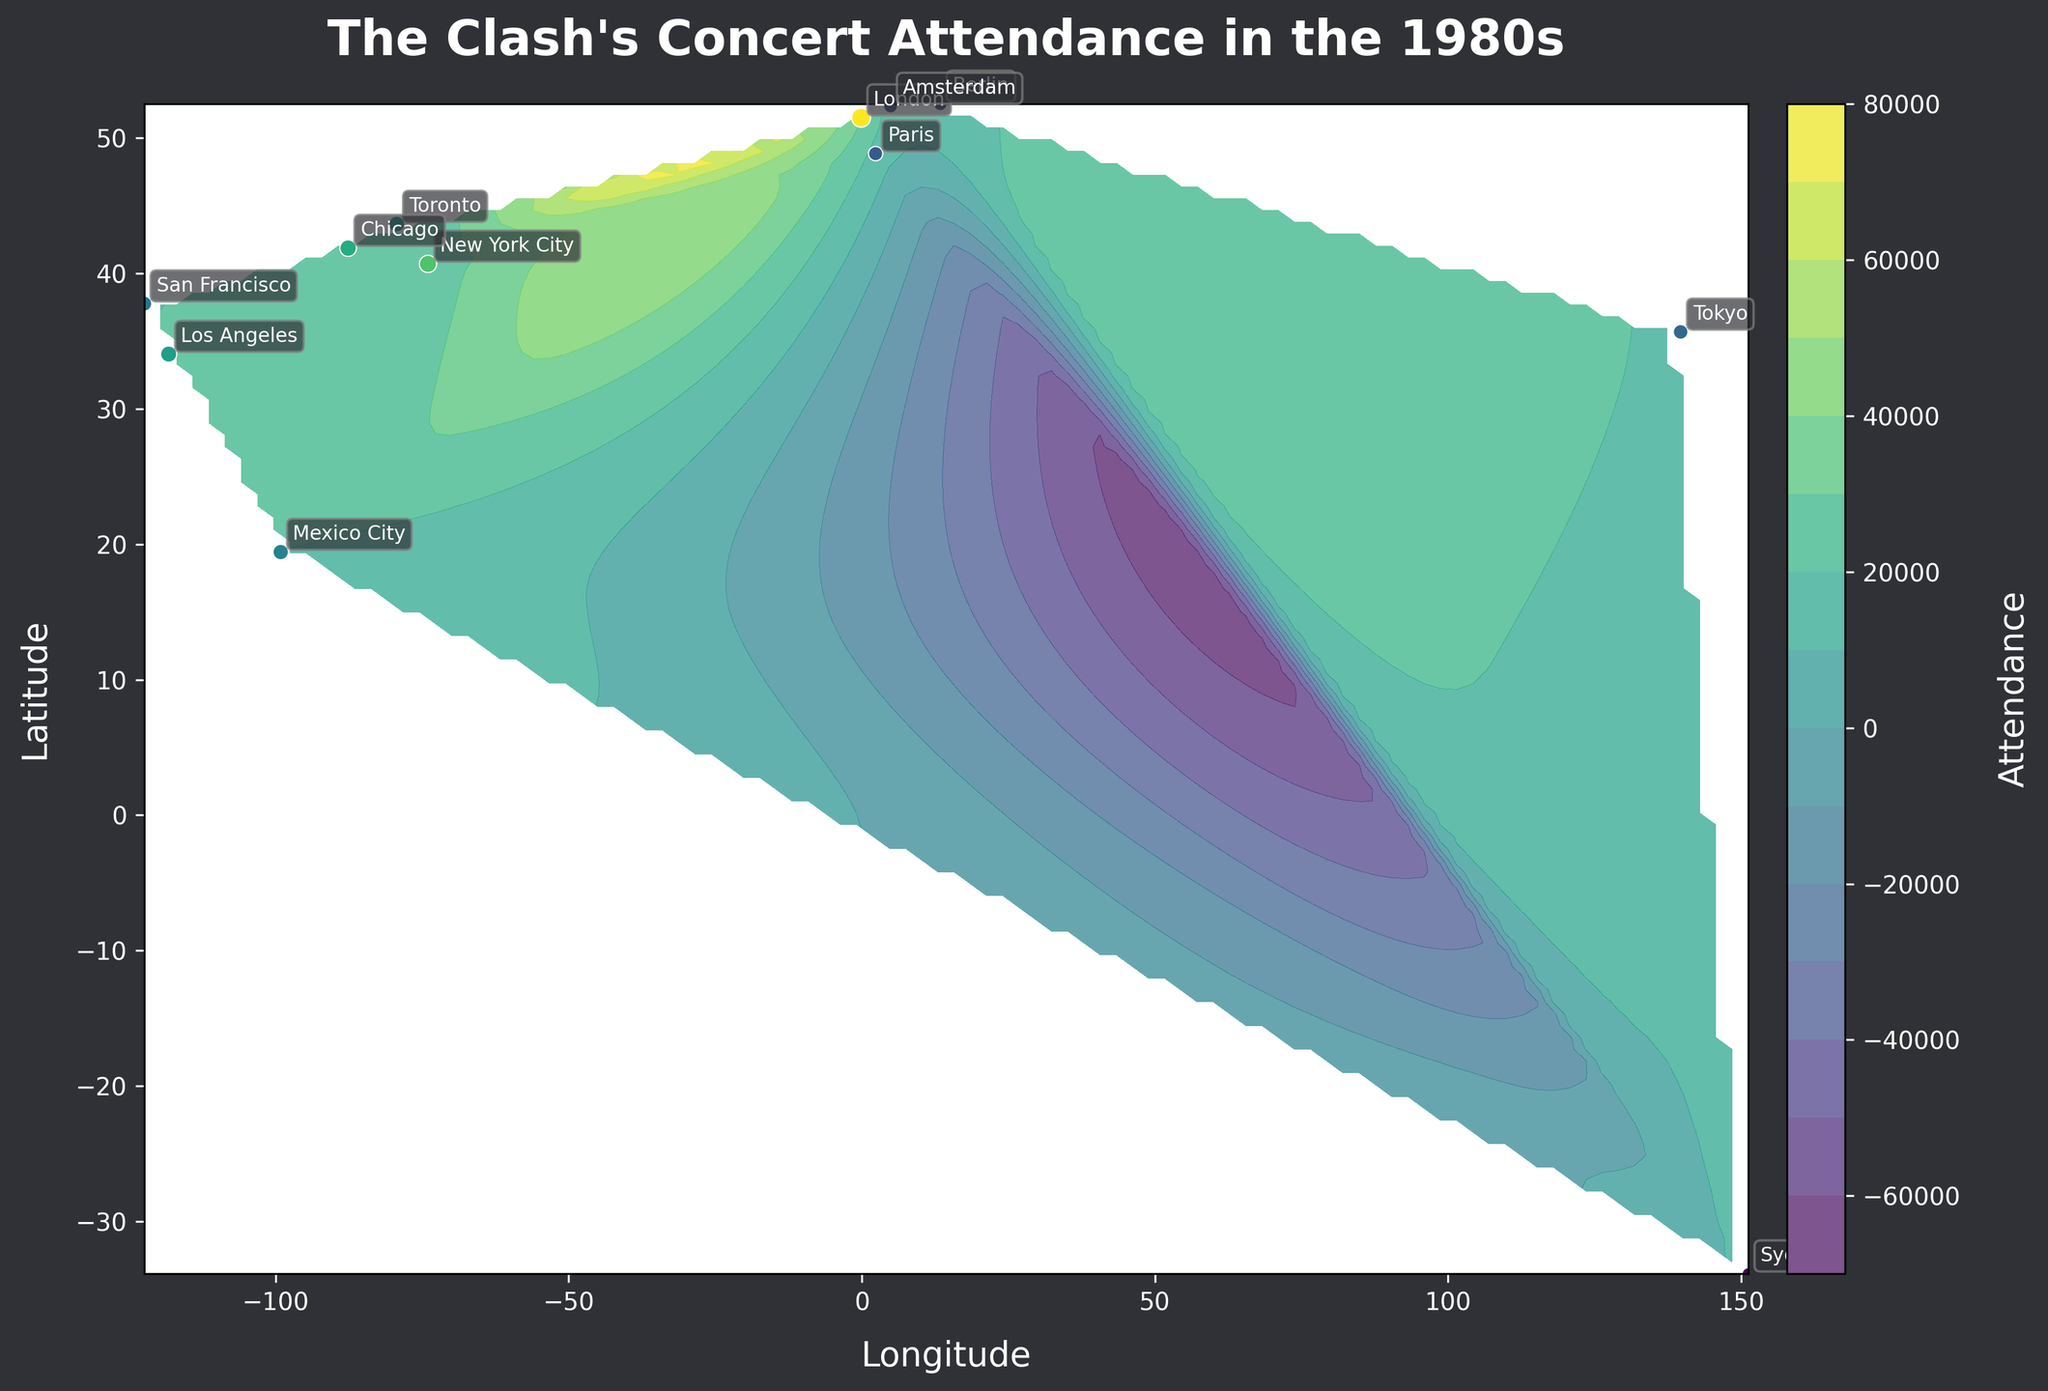What's the title of the figure? The title is located at the top of the figure, usually in a larger, bold font to stand out.
Answer: The Clash's Concert Attendance in the 1980s How many cities were included in the plot? You can count the number of labeled points on the contour plot, each representing a city.
Answer: 12 Which city had the highest attendance at The Clash's concerts? Look for the city label next to the highest scatter point.
Answer: London Which city is more to the west, New York City or Los Angeles? Compare the longitude values for the two cities. Lower longitude values indicate more western locations.
Answer: Los Angeles What is the range of attendance values in the plot? Identify the highest and lowest attendance values among all scatter points. The range is the difference between these two values.
Answer: 12000 to 30000 Which city had an attendance close to 20000? Find the scatter points with attendance close to the specified number and then check the labels next to these scatter points.
Answer: Mexico City What is the average attendance across all cities? Sum the attendance values and then divide by the number of cities. \( (25000+22000+30000+18000+12000+15000+17000+21000+20000+23000+19000+16000) / 12 \)
Answer: 20416.67 Between Paris and Berlin, which city had higher attendance? Compare the attendance values for these two cities and check the labels next to the corresponding scatter points.
Answer: Paris Which area, Europe or North America, had a higher average attendance? Separate the cities into European and North American groups, sum up the attendances for each group, and compute their averages. Europe: \(30000 + 15000 + 17000 + 16000 = 78000\). North America: \(25000 + 22000 + 21000 + 20000 + 23000 + 19000 = 130000\). Divide each by the number of contributing cities.
Answer: North America What color range is used for representing attendance levels on the contour plot? Refer to the color bar legend to understand the gradient representing different attendance levels.
Answer: Shades of purple and yellow 